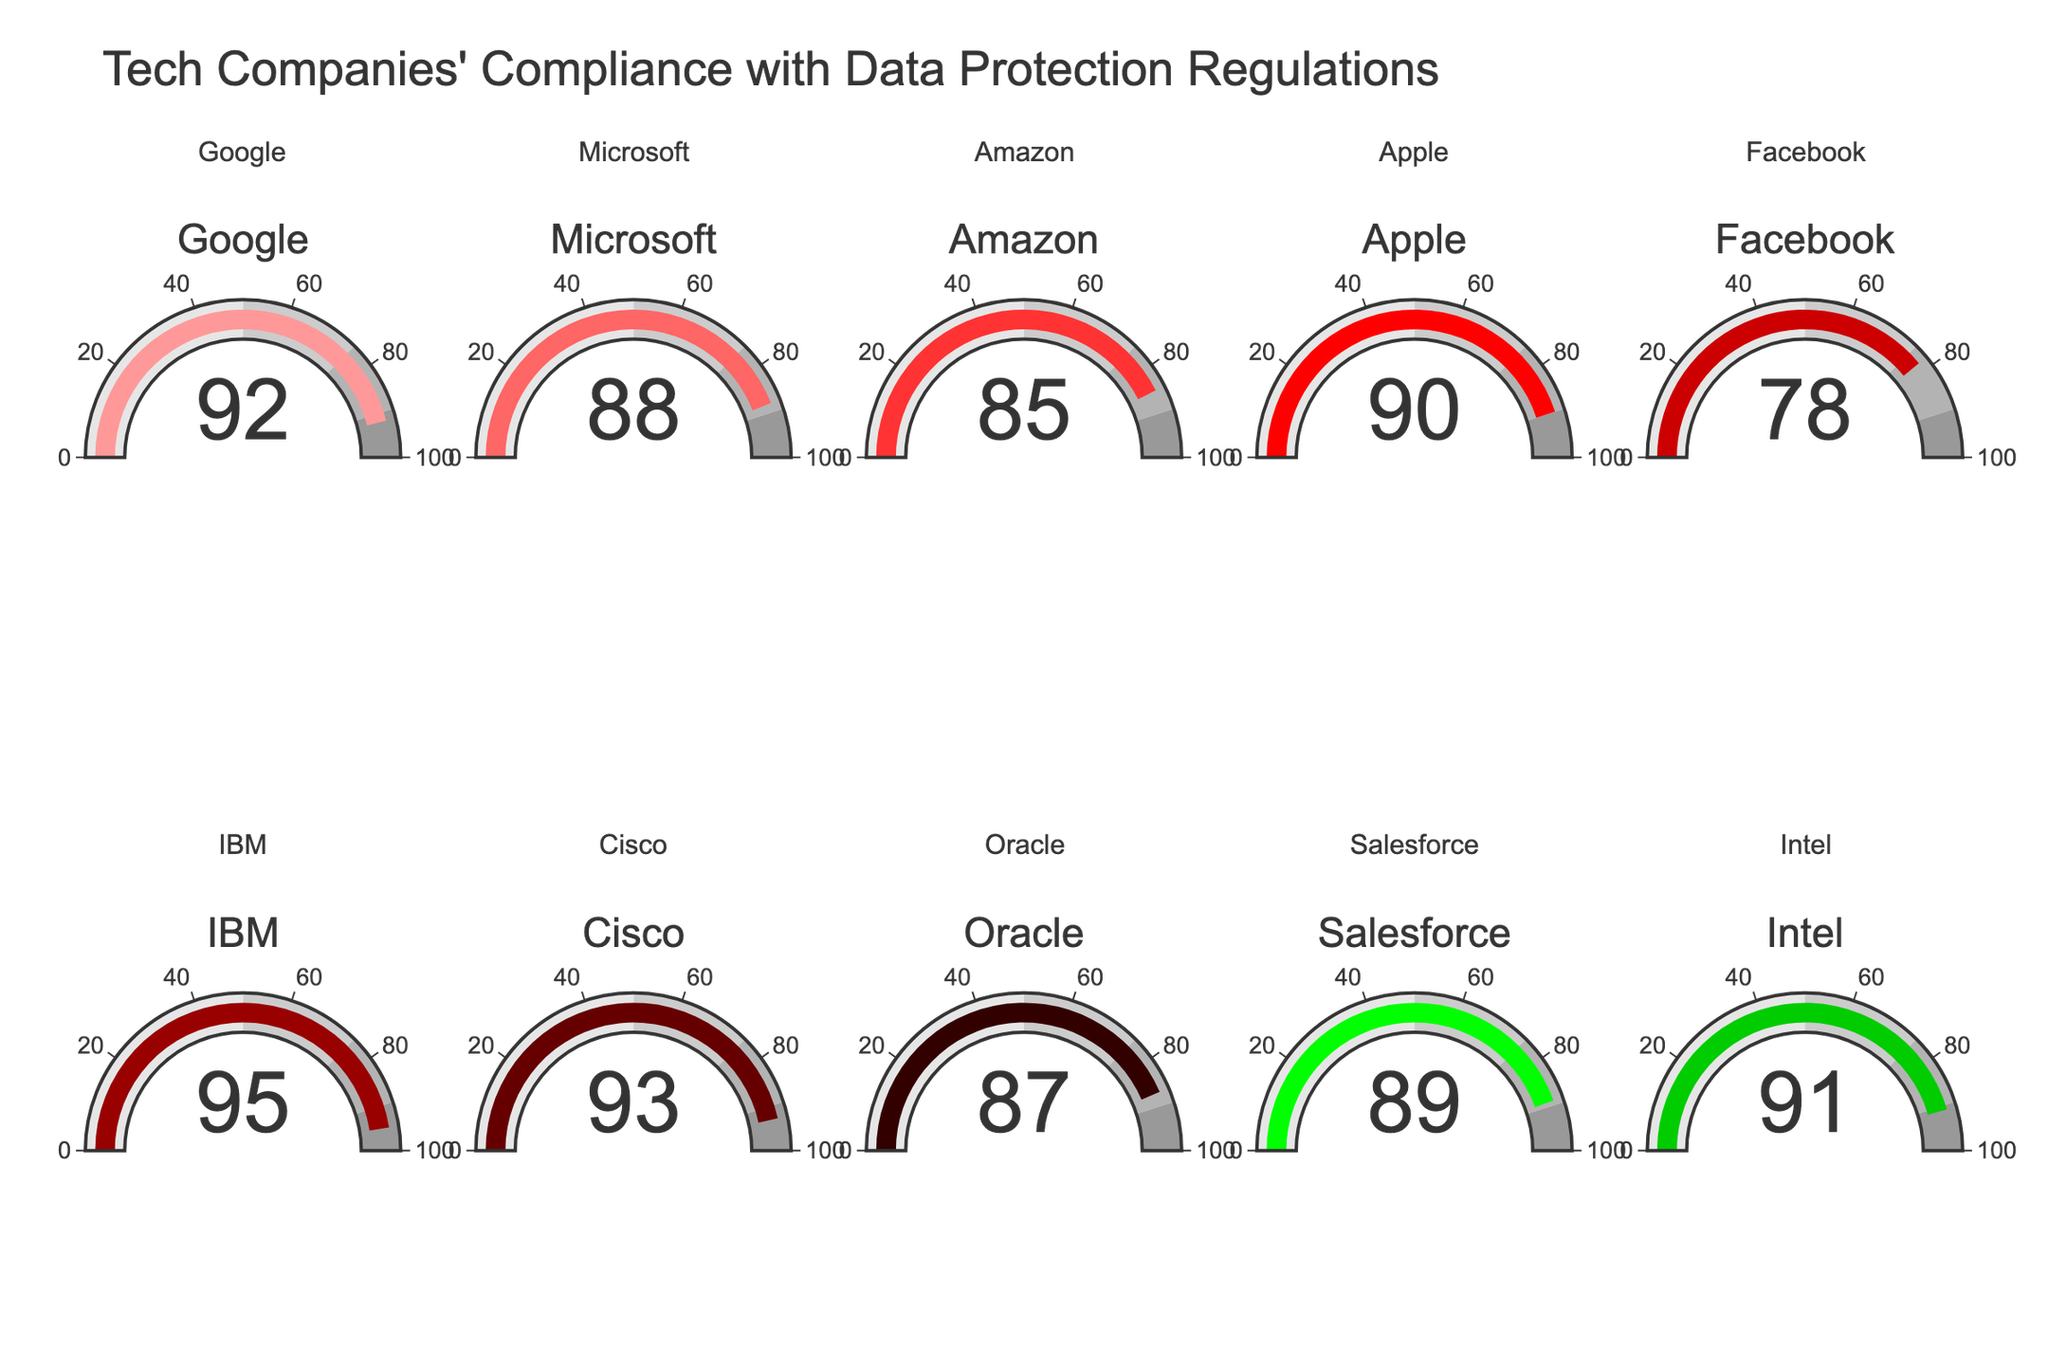Which company has the highest compliance percentage? IBM has the highest compliance percentage. We can identify this by scanning all the gauge charts for the highest number. IBM shows a 95% compliance percentage.
Answer: IBM Which company has the lowest compliance percentage? Facebook has the lowest compliance percentage. This can be seen by checking each gauge chart and finding the smallest number. Facebook shows a 78% compliance percentage.
Answer: Facebook What's the median compliance percentage among the tech companies? To find the median, list all the compliance percentages in ascending order: 78, 85, 87, 88, 89, 90, 91, 92, 93, 95. The median is the middle value, so the fifth and sixth values are 89 and 90. The median value is their average: (89 + 90) / 2 = 89.5.
Answer: 89.5 How many companies have a compliance percentage of 90% or more? We need to count the number of companies with compliance percentages of 90 or above. Companies with 90% or more are Google (92), Apple (90), IBM (95), Cisco (93), and Intel (91). This makes a total of 5 companies.
Answer: 5 What is the total compliance percentage of Google, Microsoft, and Apple combined? Sum the compliance percentages of Google, Microsoft, and Apple: Google (92) + Microsoft (88) + Apple (90) = 270.
Answer: 270 Which company has a compliance percentage closest to 85%? By comparing the deviations, Amazon has the compliance percentage closest to 85%, with exactly 85%. The next closest percentages are 87% (Oracle) and 88% (Microsoft).
Answer: Amazon How much higher is Cisco's compliance percentage compared to Facebook's? Subtract Facebook's compliance percentage from Cisco's: Cisco (93) - Facebook (78) = 15.
Answer: 15 What percentage range do most of the companies fall into? Most companies fall in the 85%-95% range, as seven out of ten companies have compliance percentages between 85% and 95%.
Answer: 85%-95% How does Salesforce’s compliance percentage compare with the average compliance percentage? First, calculate the average: (92 + 88 + 85 + 90 + 78 + 95 + 93 + 87 + 89 + 91) / 10 = 88.8. Salesforce's compliance percentage is 89, which is slightly above the average.
Answer: Slightly above average What’s the difference between the highest and lowest compliance percentages? Subtract the lowest compliance percentage from the highest: 95 (IBM) - 78 (Facebook) = 17.
Answer: 17 